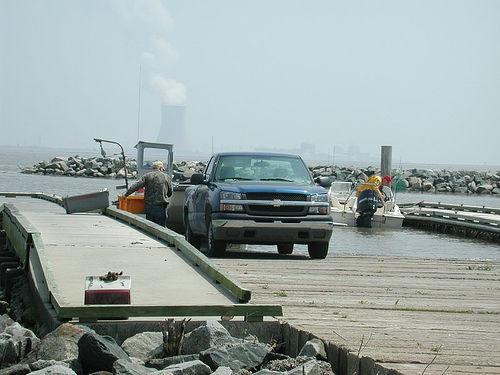What type of truck is this?
Keep it brief. Chevy. Is the truck sinking?
Concise answer only. No. What is the truck doing?
Give a very brief answer. Unloading boat. 